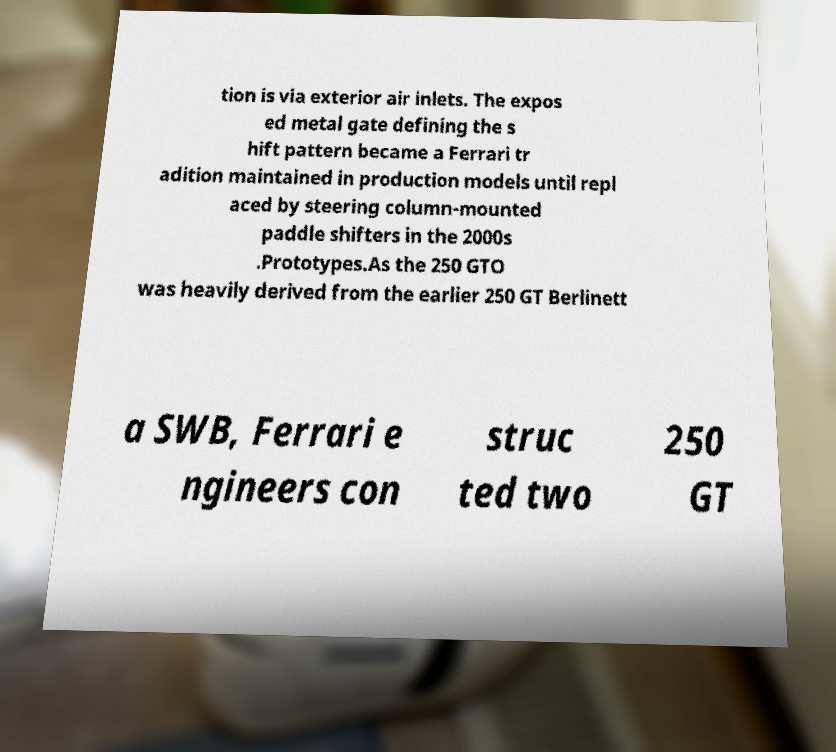I need the written content from this picture converted into text. Can you do that? tion is via exterior air inlets. The expos ed metal gate defining the s hift pattern became a Ferrari tr adition maintained in production models until repl aced by steering column-mounted paddle shifters in the 2000s .Prototypes.As the 250 GTO was heavily derived from the earlier 250 GT Berlinett a SWB, Ferrari e ngineers con struc ted two 250 GT 